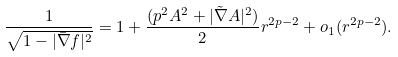Convert formula to latex. <formula><loc_0><loc_0><loc_500><loc_500>\frac { 1 } { \sqrt { 1 - | \bar { \nabla } f | ^ { 2 } } } = 1 + \frac { ( p ^ { 2 } A ^ { 2 } + | \tilde { \nabla } A | ^ { 2 } ) } { 2 } r ^ { 2 p - 2 } + o _ { 1 } ( r ^ { 2 p - 2 } ) .</formula> 